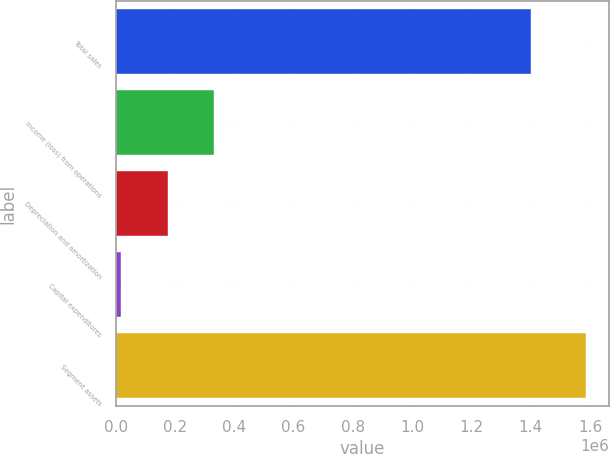Convert chart to OTSL. <chart><loc_0><loc_0><loc_500><loc_500><bar_chart><fcel>Total sales<fcel>Income (loss) from operations<fcel>Depreciation and amortization<fcel>Capital expenditures<fcel>Segment assets<nl><fcel>1.40162e+06<fcel>331797<fcel>175043<fcel>18288<fcel>1.58584e+06<nl></chart> 